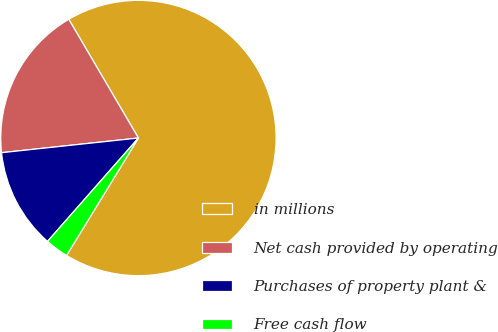Convert chart. <chart><loc_0><loc_0><loc_500><loc_500><pie_chart><fcel>in millions<fcel>Net cash provided by operating<fcel>Purchases of property plant &<fcel>Free cash flow<nl><fcel>67.18%<fcel>18.26%<fcel>11.82%<fcel>2.74%<nl></chart> 